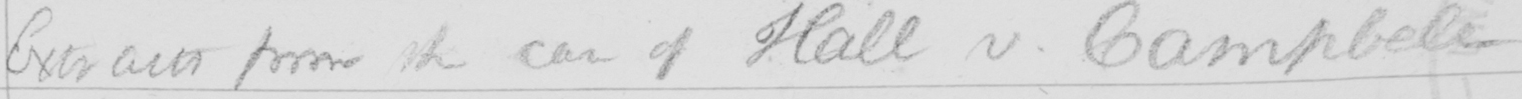Please transcribe the handwritten text in this image. Extracts from the case of Hall v . Campbell 